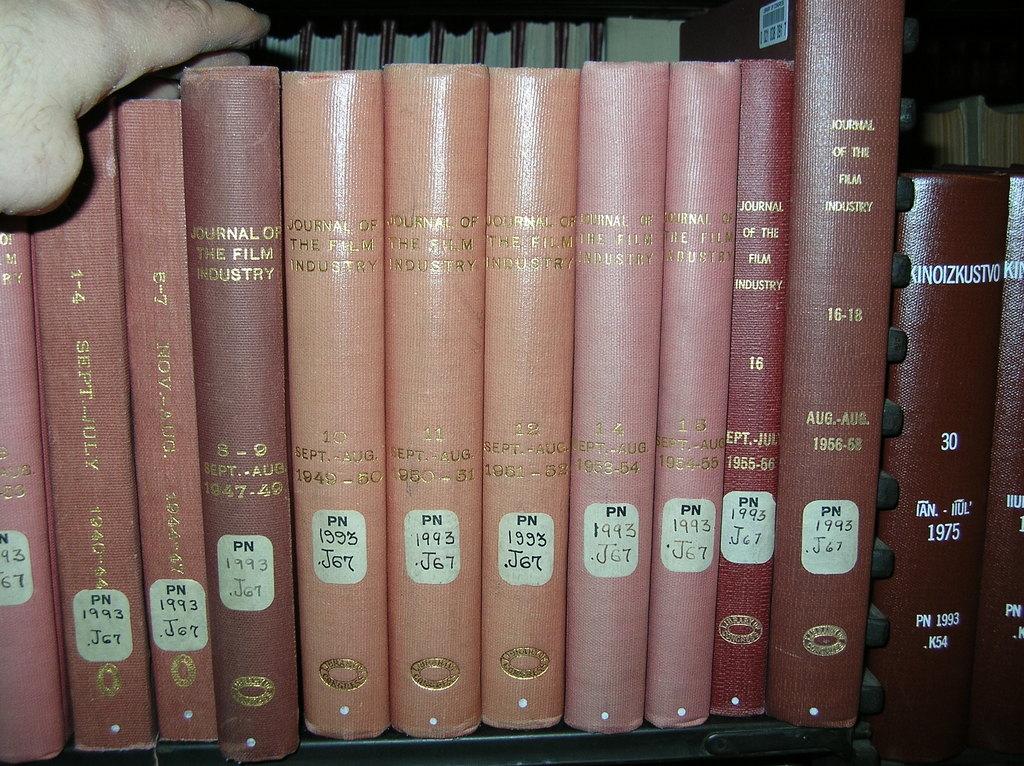What industry are these journals about?
Your answer should be very brief. Film. What year were these from?
Offer a terse response. 1993. 